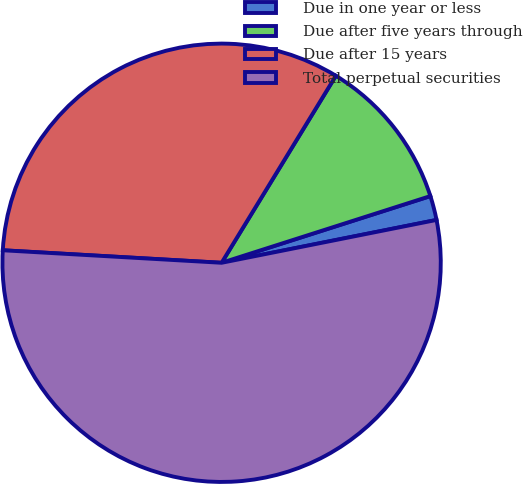Convert chart to OTSL. <chart><loc_0><loc_0><loc_500><loc_500><pie_chart><fcel>Due in one year or less<fcel>Due after five years through<fcel>Due after 15 years<fcel>Total perpetual securities<nl><fcel>1.79%<fcel>11.35%<fcel>32.82%<fcel>54.04%<nl></chart> 